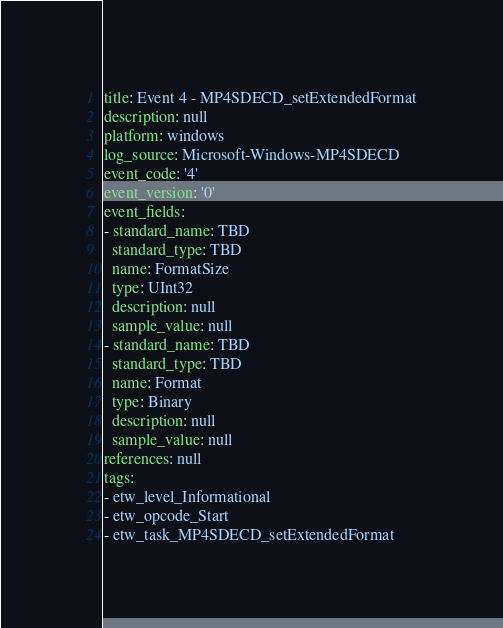<code> <loc_0><loc_0><loc_500><loc_500><_YAML_>title: Event 4 - MP4SDECD_setExtendedFormat
description: null
platform: windows
log_source: Microsoft-Windows-MP4SDECD
event_code: '4'
event_version: '0'
event_fields:
- standard_name: TBD
  standard_type: TBD
  name: FormatSize
  type: UInt32
  description: null
  sample_value: null
- standard_name: TBD
  standard_type: TBD
  name: Format
  type: Binary
  description: null
  sample_value: null
references: null
tags:
- etw_level_Informational
- etw_opcode_Start
- etw_task_MP4SDECD_setExtendedFormat
</code> 